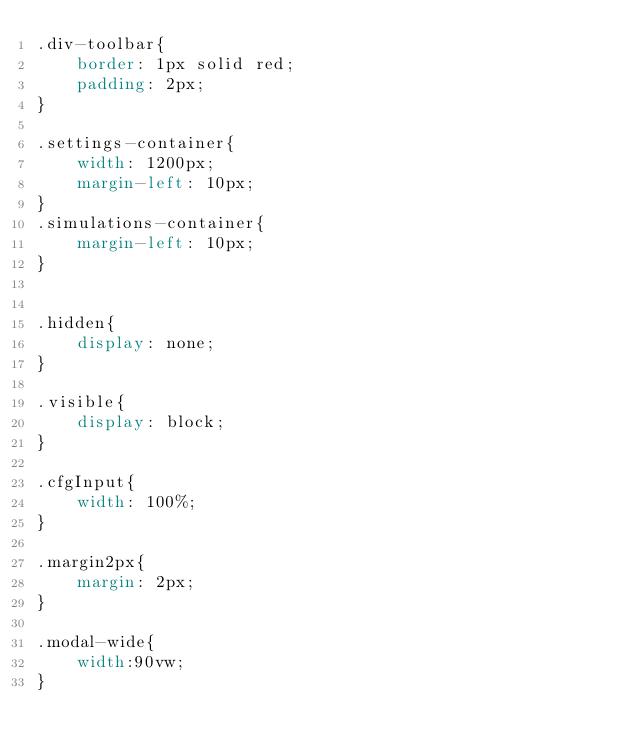<code> <loc_0><loc_0><loc_500><loc_500><_CSS_>.div-toolbar{
    border: 1px solid red;
    padding: 2px;
}

.settings-container{
    width: 1200px;
    margin-left: 10px;
}
.simulations-container{
    margin-left: 10px;
}


.hidden{
    display: none;
}

.visible{
    display: block;
}

.cfgInput{
    width: 100%;
}

.margin2px{
    margin: 2px;
}

.modal-wide{
    width:90vw;
}</code> 